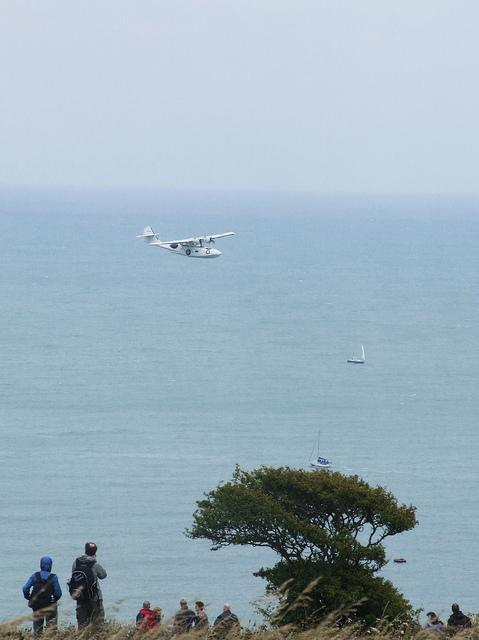Which thing here is the highest? Please explain your reasoning. airplane. The airplane is flying through the air and there's nothing else in the air at the moment, so the airplane is definitely the highest object. 